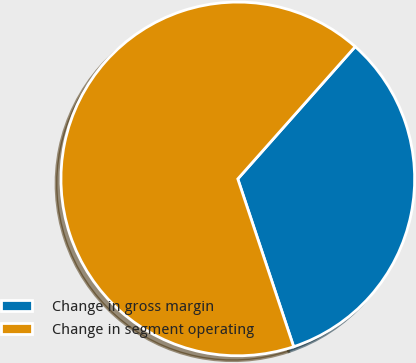<chart> <loc_0><loc_0><loc_500><loc_500><pie_chart><fcel>Change in gross margin<fcel>Change in segment operating<nl><fcel>33.33%<fcel>66.67%<nl></chart> 